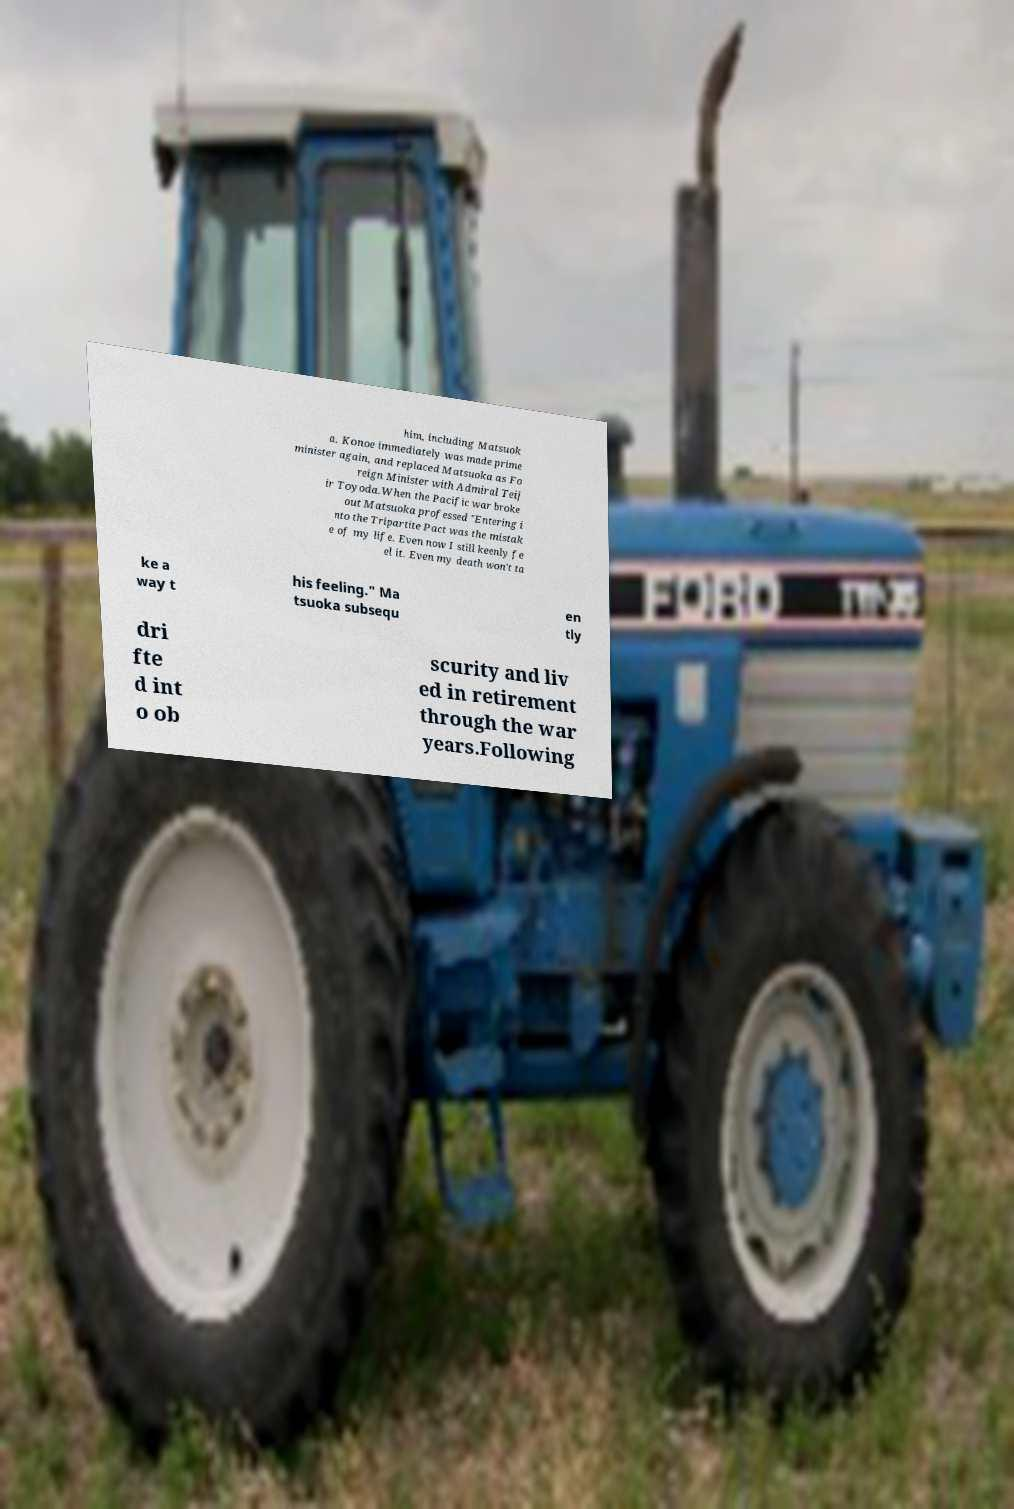Please read and relay the text visible in this image. What does it say? him, including Matsuok a. Konoe immediately was made prime minister again, and replaced Matsuoka as Fo reign Minister with Admiral Teij ir Toyoda.When the Pacific war broke out Matsuoka professed "Entering i nto the Tripartite Pact was the mistak e of my life. Even now I still keenly fe el it. Even my death won't ta ke a way t his feeling." Ma tsuoka subsequ en tly dri fte d int o ob scurity and liv ed in retirement through the war years.Following 